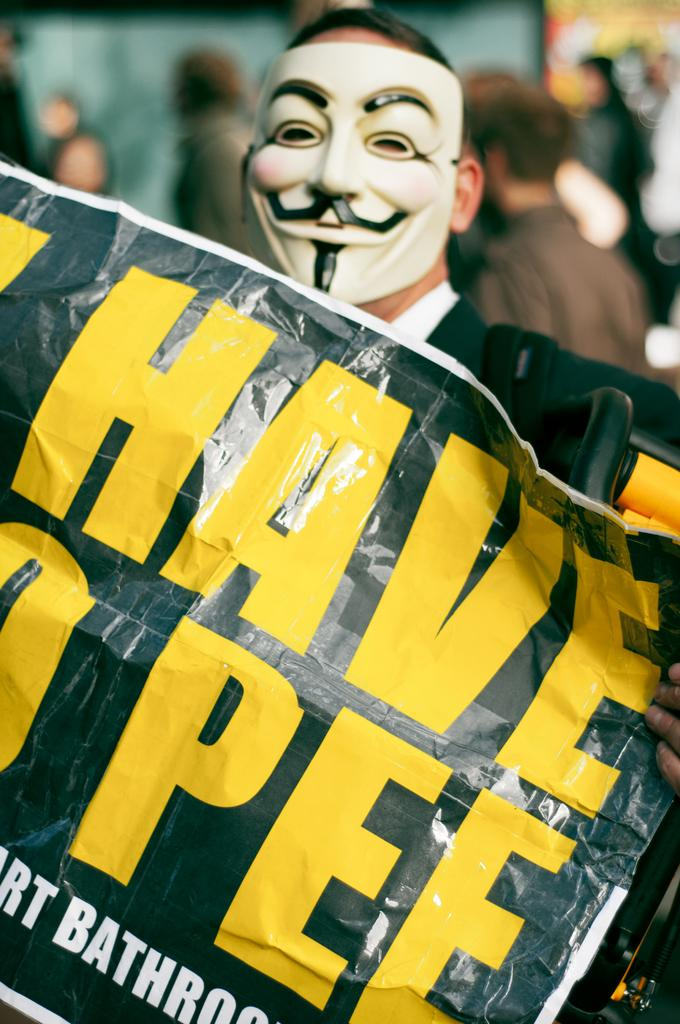What is the person in the image wearing on their face? The person in the image is wearing a mask. What is the person holding in the image? The person is holding a banner. Are there any other people visible in the image? Yes, there are a few other people behind the person with the banner. Is there a drain visible in the image? No, there is no drain present in the image. Are the people in the image pushing each other? There is no indication in the image that the people are pushing each other. 